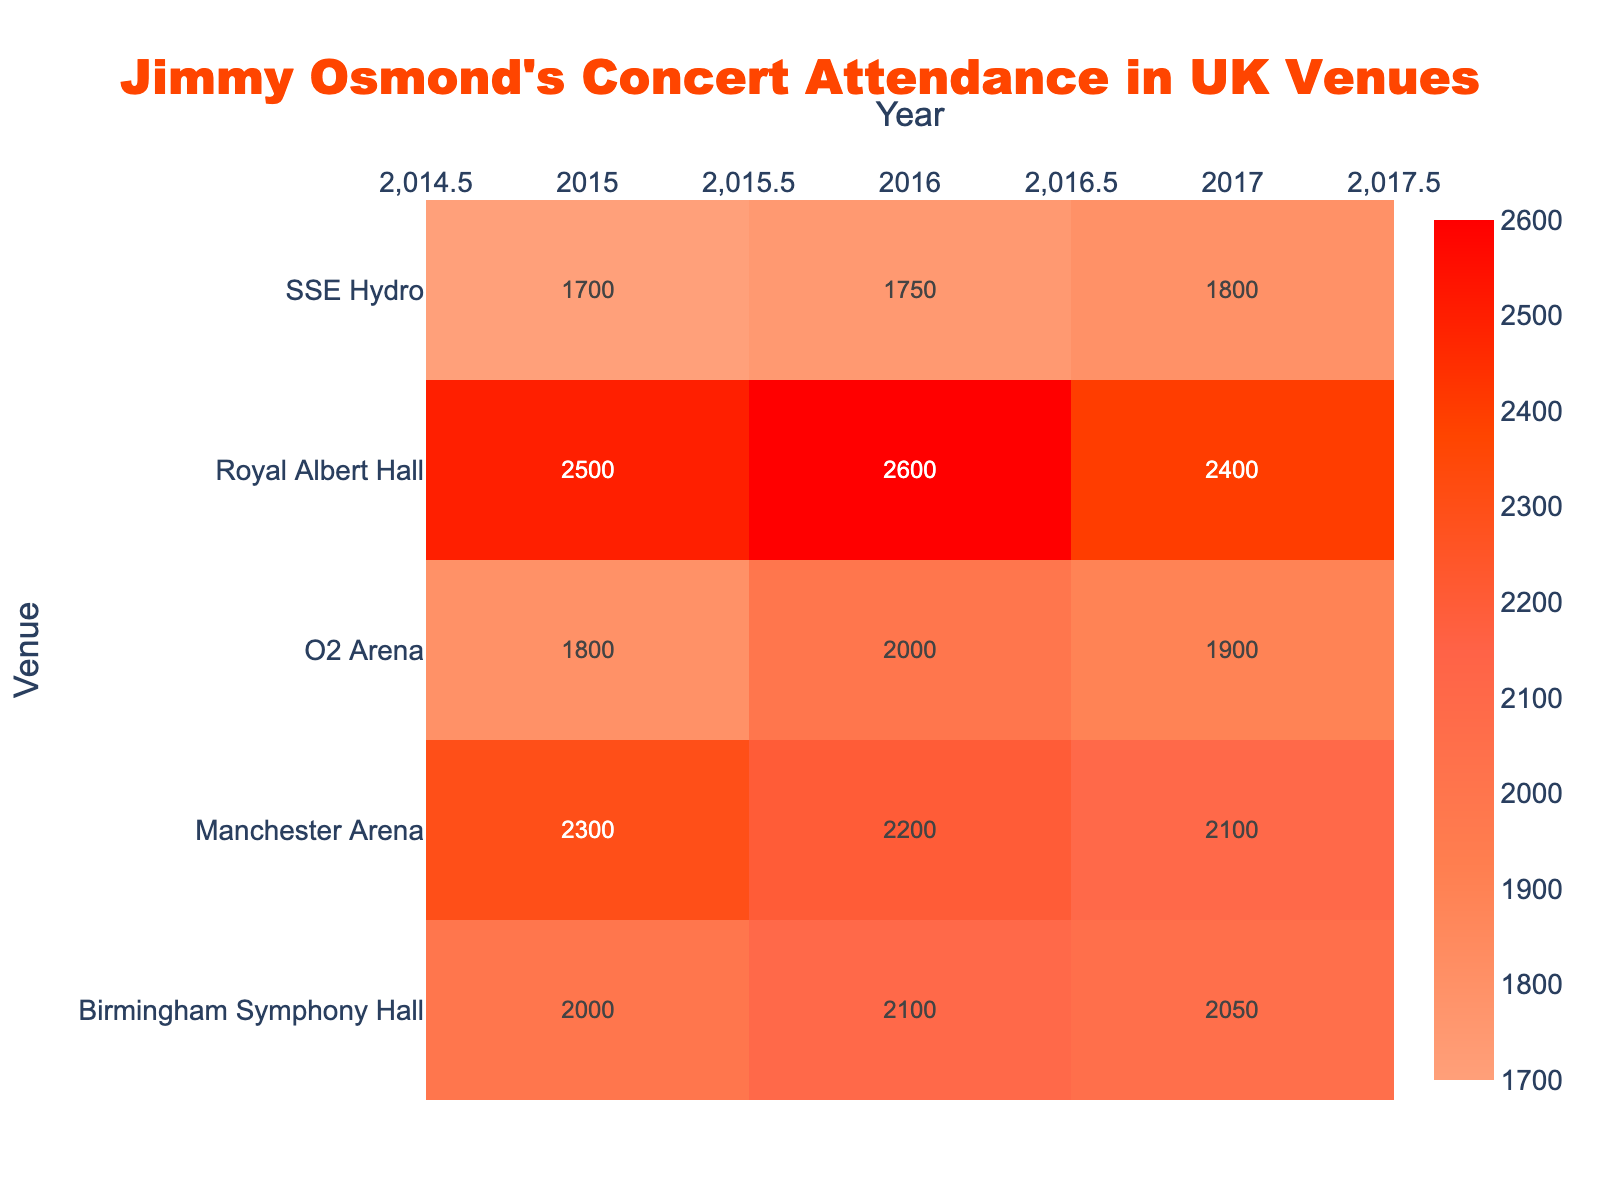What's the title of the heatmap? The title is given at the very top of the figure, and it reads: "Jimmy Osmond's Concert Attendance in UK Venues".
Answer: Jimmy Osmond's Concert Attendance in UK Venues Which year saw the highest attendance at the Royal Albert Hall? Find the highest value in the Royal Albert Hall row across the years 2015, 2016, and 2017. In 2016, the attendance was 2600, which is the highest.
Answer: 2016 What is the difference in attendance between O2 Arena and Manchester Arena in 2015? Subtract the attendance figure of O2 Arena in 2015 (1800) from that of Manchester Arena in 2015 (2300). The difference is thus 500.
Answer: 500 Which venue had the lowest attendance in 2017? Examine the attendance figures for each venue in the year 2017. The SSE Hydro had the lowest attendance with 1800.
Answer: SSE Hydro What is the average attendance at Birmingham Symphony Hall over the three years? Add the attendance figures for Birmingham Symphony Hall across 2015 (2000), 2016 (2100), and 2017 (2050). Then divide by 3. (2000 + 2100 + 2050) / 3 = 2050.
Answer: 2050 Which venue shows an increasing trend in attendance over the years? Check each venue for a consistent increase in attendance from 2015 to 2017. SSE Hydro shows a steady increase from 1700 in 2015 to 1750 in 2016 to 1800 in 2017.
Answer: SSE Hydro Did any venue record an attendance exactly equal to 2500 in any year? Look at the text within the heatmap cells for any attendance values of 2500. The Royal Albert Hall recorded an attendance of 2500 in 2015.
Answer: Yes, Royal Albert Hall in 2015 Which venue had a consistent decrease in attendance over the years? Look for a venue where the attendance figures decrease each year from 2015 to 2017. Manchester Arena's figures decrease from 2300 in 2015 to 2200 in 2016 to 2100 in 2017.
Answer: Manchester Arena What is the total attendance for all venues combined in 2016? Sum the attendance for all venues in the year 2016: 2600 (Royal Albert Hall) + 2000 (O2 Arena) + 2200 (Manchester Arena) + 2100 (Birmingham Symphony Hall) + 1750 (SSE Hydro). Total = 10650.
Answer: 10650 